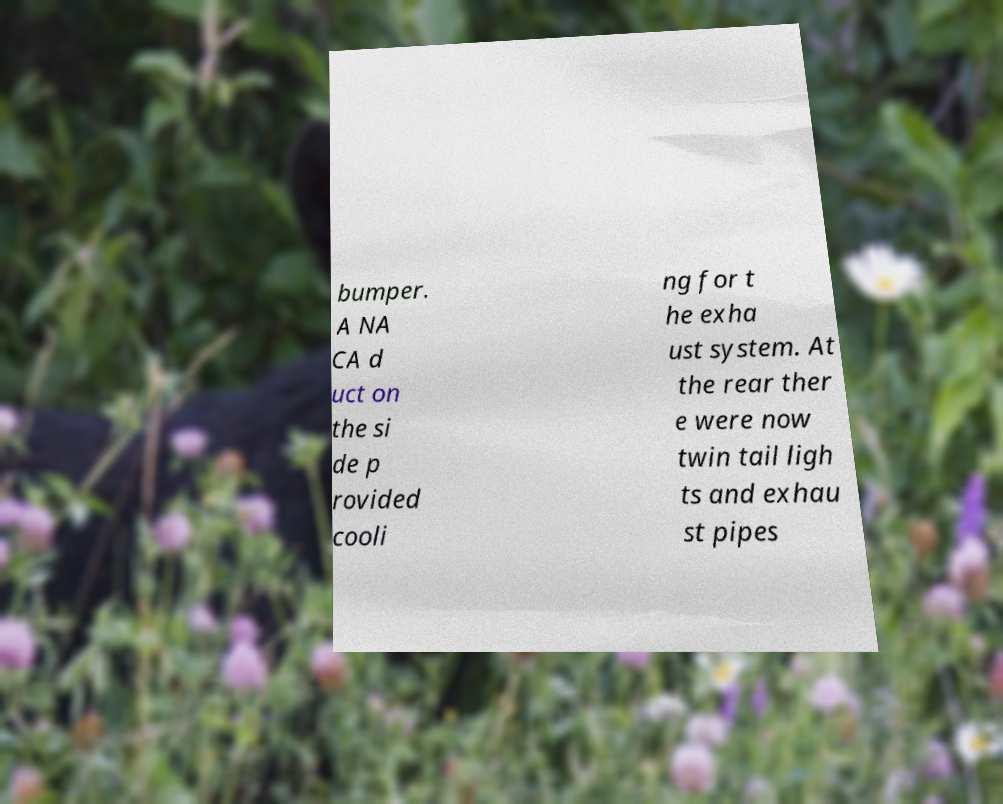Could you assist in decoding the text presented in this image and type it out clearly? bumper. A NA CA d uct on the si de p rovided cooli ng for t he exha ust system. At the rear ther e were now twin tail ligh ts and exhau st pipes 